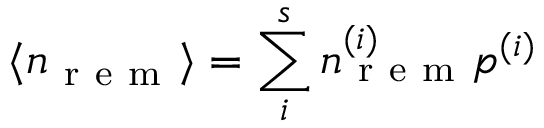Convert formula to latex. <formula><loc_0><loc_0><loc_500><loc_500>\langle n _ { r e m } \rangle = \sum _ { i } ^ { s } n _ { r e m } ^ { ( i ) } p ^ { ( i ) }</formula> 